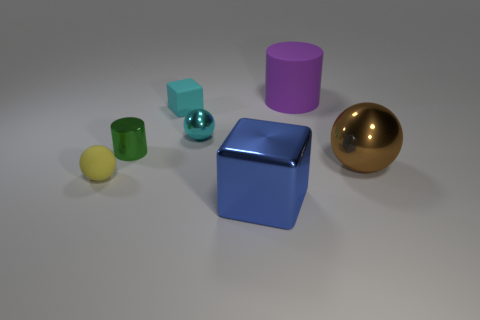Are there any yellow rubber spheres that are in front of the large metallic object left of the big purple matte thing?
Your response must be concise. No. There is a large metallic object behind the tiny sphere in front of the tiny cyan metal ball; is there a large purple matte cylinder that is in front of it?
Keep it short and to the point. No. Do the large shiny thing to the left of the large brown sphere and the shiny object that is to the right of the big purple object have the same shape?
Offer a terse response. No. What color is the cylinder that is the same material as the small yellow ball?
Make the answer very short. Purple. How big is the cylinder that is on the left side of the small matte object that is behind the tiny thing that is to the left of the small cylinder?
Make the answer very short. Small. Is the material of the small ball that is right of the tiny matte ball the same as the big blue thing?
Ensure brevity in your answer.  Yes. There is a small sphere that is the same color as the small cube; what material is it?
Offer a very short reply. Metal. Are there any other things that have the same shape as the large blue metal object?
Provide a succinct answer. Yes. How many objects are either large blue things or shiny balls?
Offer a very short reply. 3. There is another green object that is the same shape as the large matte thing; what is its size?
Your response must be concise. Small. 